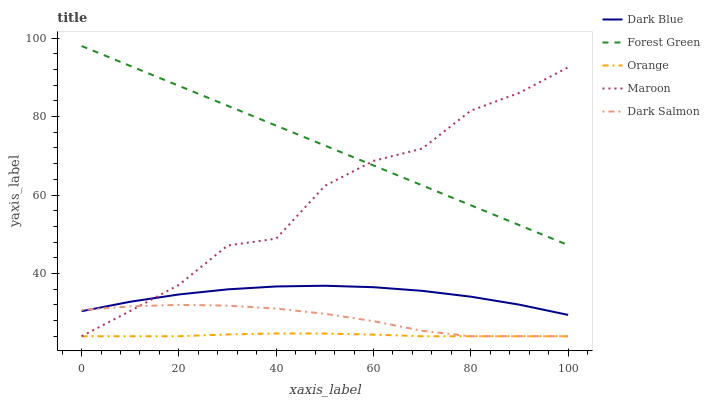Does Dark Blue have the minimum area under the curve?
Answer yes or no. No. Does Dark Blue have the maximum area under the curve?
Answer yes or no. No. Is Dark Blue the smoothest?
Answer yes or no. No. Is Dark Blue the roughest?
Answer yes or no. No. Does Dark Blue have the lowest value?
Answer yes or no. No. Does Dark Blue have the highest value?
Answer yes or no. No. Is Orange less than Forest Green?
Answer yes or no. Yes. Is Forest Green greater than Dark Blue?
Answer yes or no. Yes. Does Orange intersect Forest Green?
Answer yes or no. No. 